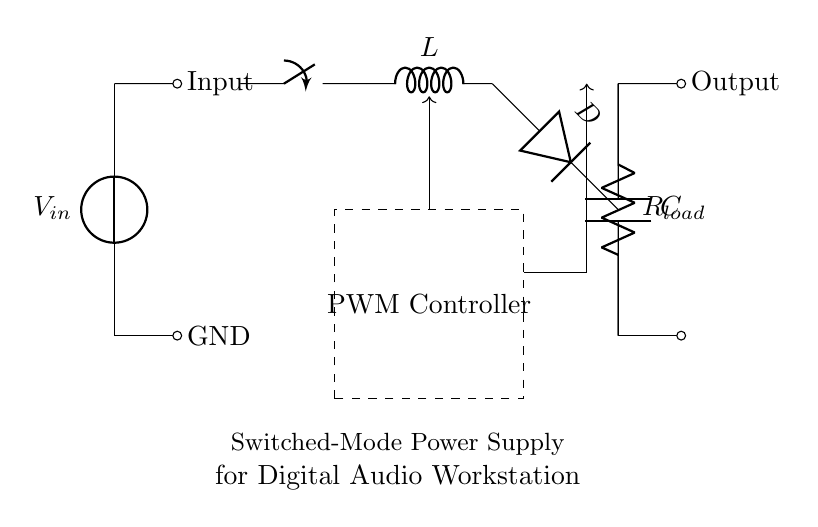What is the input voltage represented in the circuit? The circuit shows a voltage source labeled as \( V_{in} \) at the input, indicating the input voltage.
Answer: \( V_{in} \) What component is used to store energy in the circuit? The inductor labeled \( L \) is responsible for storing energy in the circuit through a magnetic field when current passes through it.
Answer: Inductor What is the function of the PWM controller? The PWM (Pulse Width Modulation) controller regulates the switching of the circuit to efficiently control the output voltage by varying the duty cycle of the switch.
Answer: Control output voltage How does the diode function in this circuit? The diode labeled \( D \) allows current to flow in only one direction, preventing backflow and ensuring that energy stored in the inductor is transferred to the load when the switch is off.
Answer: Prevent backflow What is the relationship between the inductor and the load resistance? The inductor transfers energy to the load resistance \( R_{load} \) during the switching cycle, providing a smoother output current and voltage to the load.
Answer: Energy transfer What role does the capacitor play in this circuit? The capacitor labeled \( C \) smooths out voltage fluctuations and provides power to the load by storing and releasing energy during the switching intervals.
Answer: Smoothing voltage How is the output of the circuit defined? The output is defined as the voltage at the node where the capacitor and load resistance \( R_{load} \) are connected, flowing from the circuit to the output point.
Answer: Output voltage 